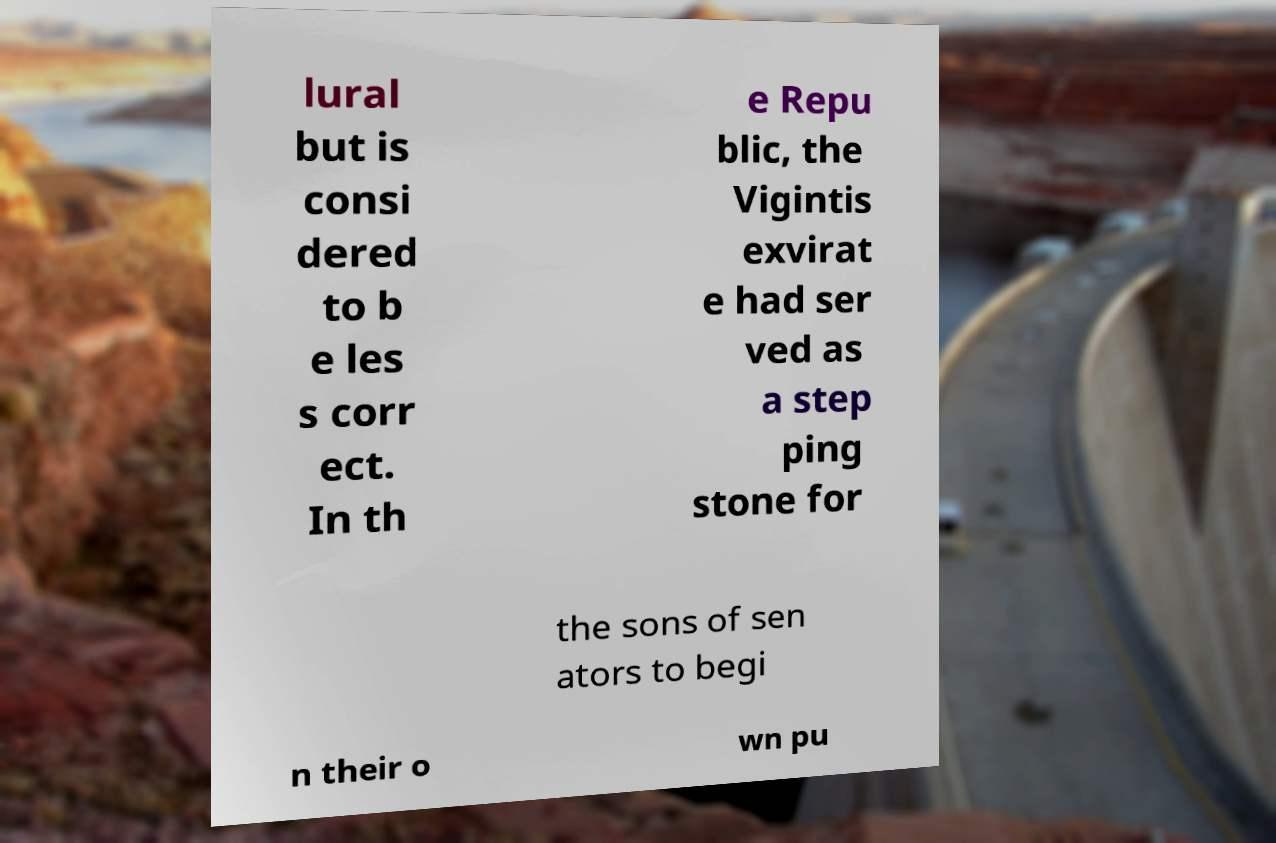Please identify and transcribe the text found in this image. lural but is consi dered to b e les s corr ect. In th e Repu blic, the Vigintis exvirat e had ser ved as a step ping stone for the sons of sen ators to begi n their o wn pu 